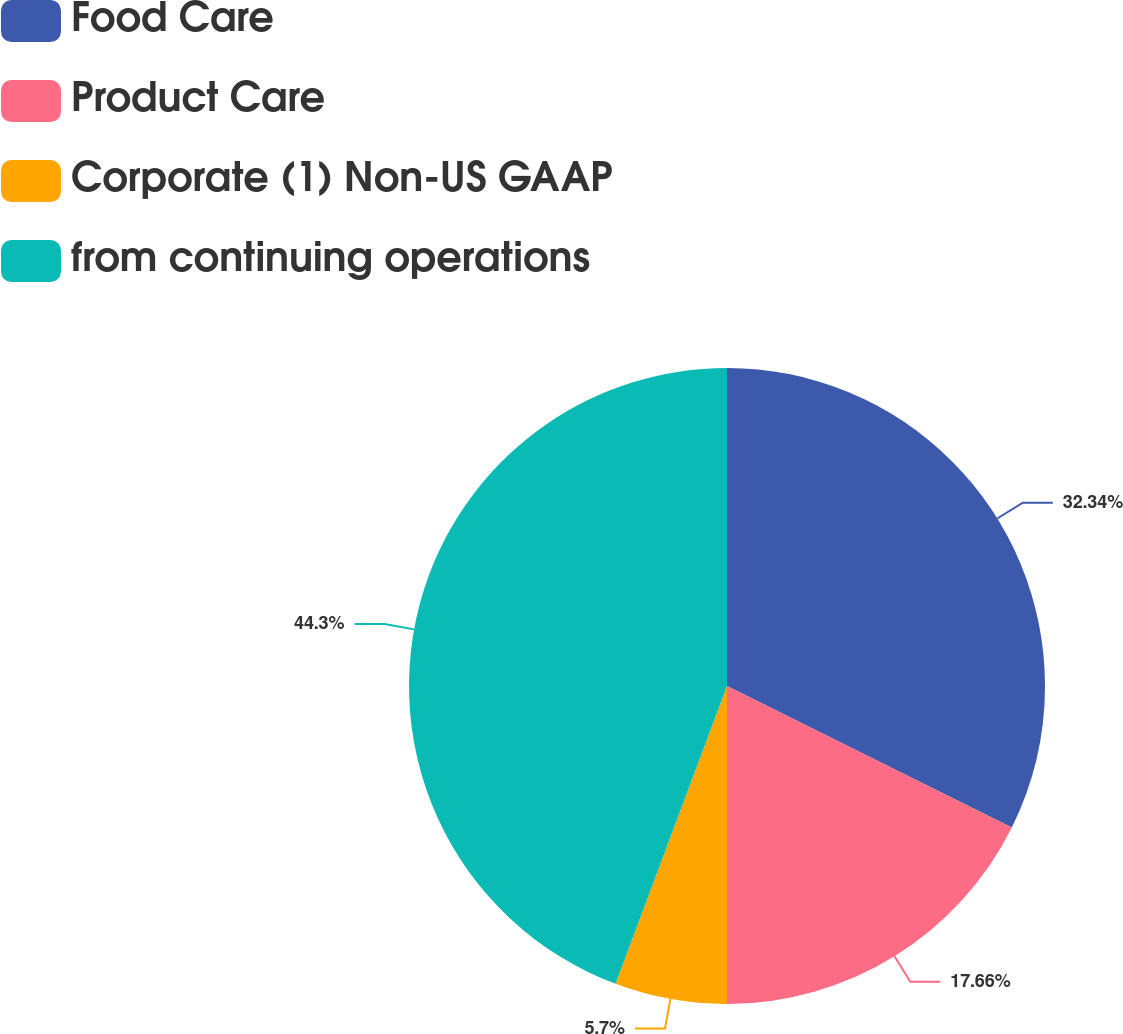Convert chart. <chart><loc_0><loc_0><loc_500><loc_500><pie_chart><fcel>Food Care<fcel>Product Care<fcel>Corporate (1) Non-US GAAP<fcel>from continuing operations<nl><fcel>32.34%<fcel>17.66%<fcel>5.7%<fcel>44.3%<nl></chart> 